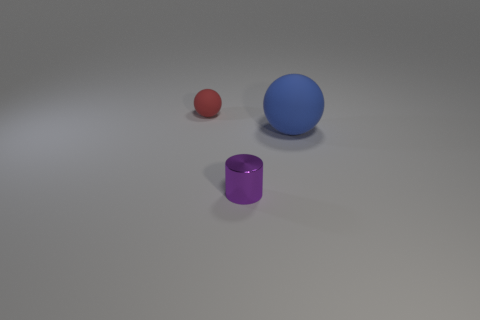What materials do the objects in the image seem to be made of? The objects in the image have a smooth texture that suggests they are likely made of a synthetic material, possibly a type of plastic or polished metal, which gives them a sleek, matte finish. 